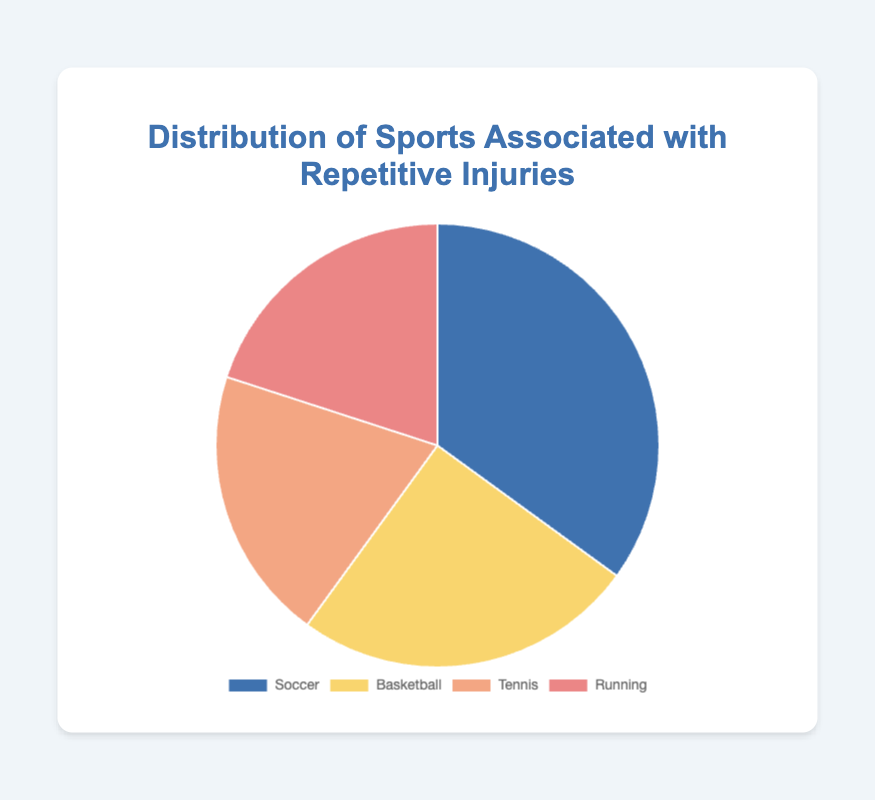What percentage of repetitive sports injuries are associated with running? Refer to the pie chart and look for the percentage associated with Running. It is labeled directly.
Answer: 20% Which sport has the highest percentage of repetitive injuries? Observe the segments of the pie chart and identify which one is the largest. The sport with the largest segment is Soccer.
Answer: Soccer How much greater is the percentage of injuries in Soccer compared to Tennis? Subtract the percentage of Tennis from that of Soccer: 35% - 20%.
Answer: 15% What is the combined percentage of injuries from Tennis and Running? Add the percentages of Tennis and Running: 20% + 20%.
Answer: 40% Which two sports have an equal percentage of repetitive injuries? Identify the sports that have the same-sized segments in the pie chart. Tennis and Running both have segments labeled 20%.
Answer: Tennis and Running How much less is the percentage of injuries from Basketball compared to Soccer? Subtract the percentage of Basketball from Soccer: 35% - 25%.
Answer: 10% If you were to combine injuries from Soccer and Basketball, what would be their total percentage? Add the percentages of Soccer and Basketball: 35% + 25%.
Answer: 60% What is the average percentage of injuries among all the sports shown? Add all the percentages and divide by the number of sports: (35% + 25% + 20% + 20%) / 4.
Answer: 25% Which sport has the smallest portion of the pie chart? Look for the smallest segment in the pie chart. Both Tennis and Running have the smallest segments.
Answer: Tennis, Running 